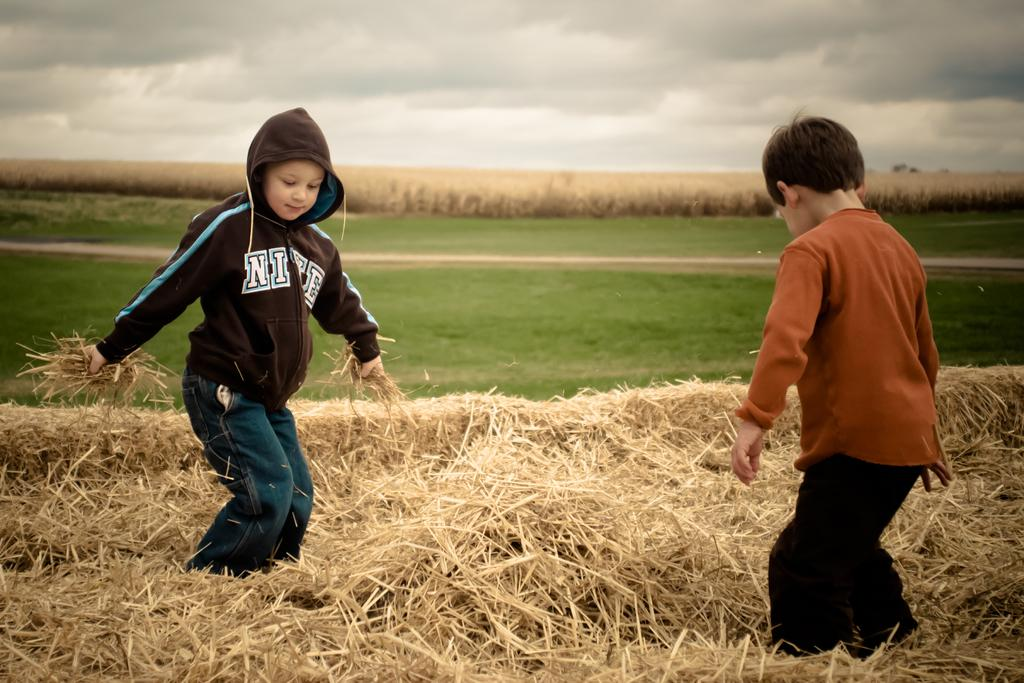How many kids are present in the image? There are two kids in the image. What are the kids doing in the image? The kids are playing in the hay. What type of vegetation can be seen in the background of the image? There is grass visible in the background of the image. What is visible in the sky in the background of the image? There are clouds in the sky in the background of the image. Is there a lead pipe visible in the image? No, there is no lead pipe present in the image. Is there a rainstorm occurring in the image? No, there is no rainstorm depicted in the image; the sky is visible with clouds. 